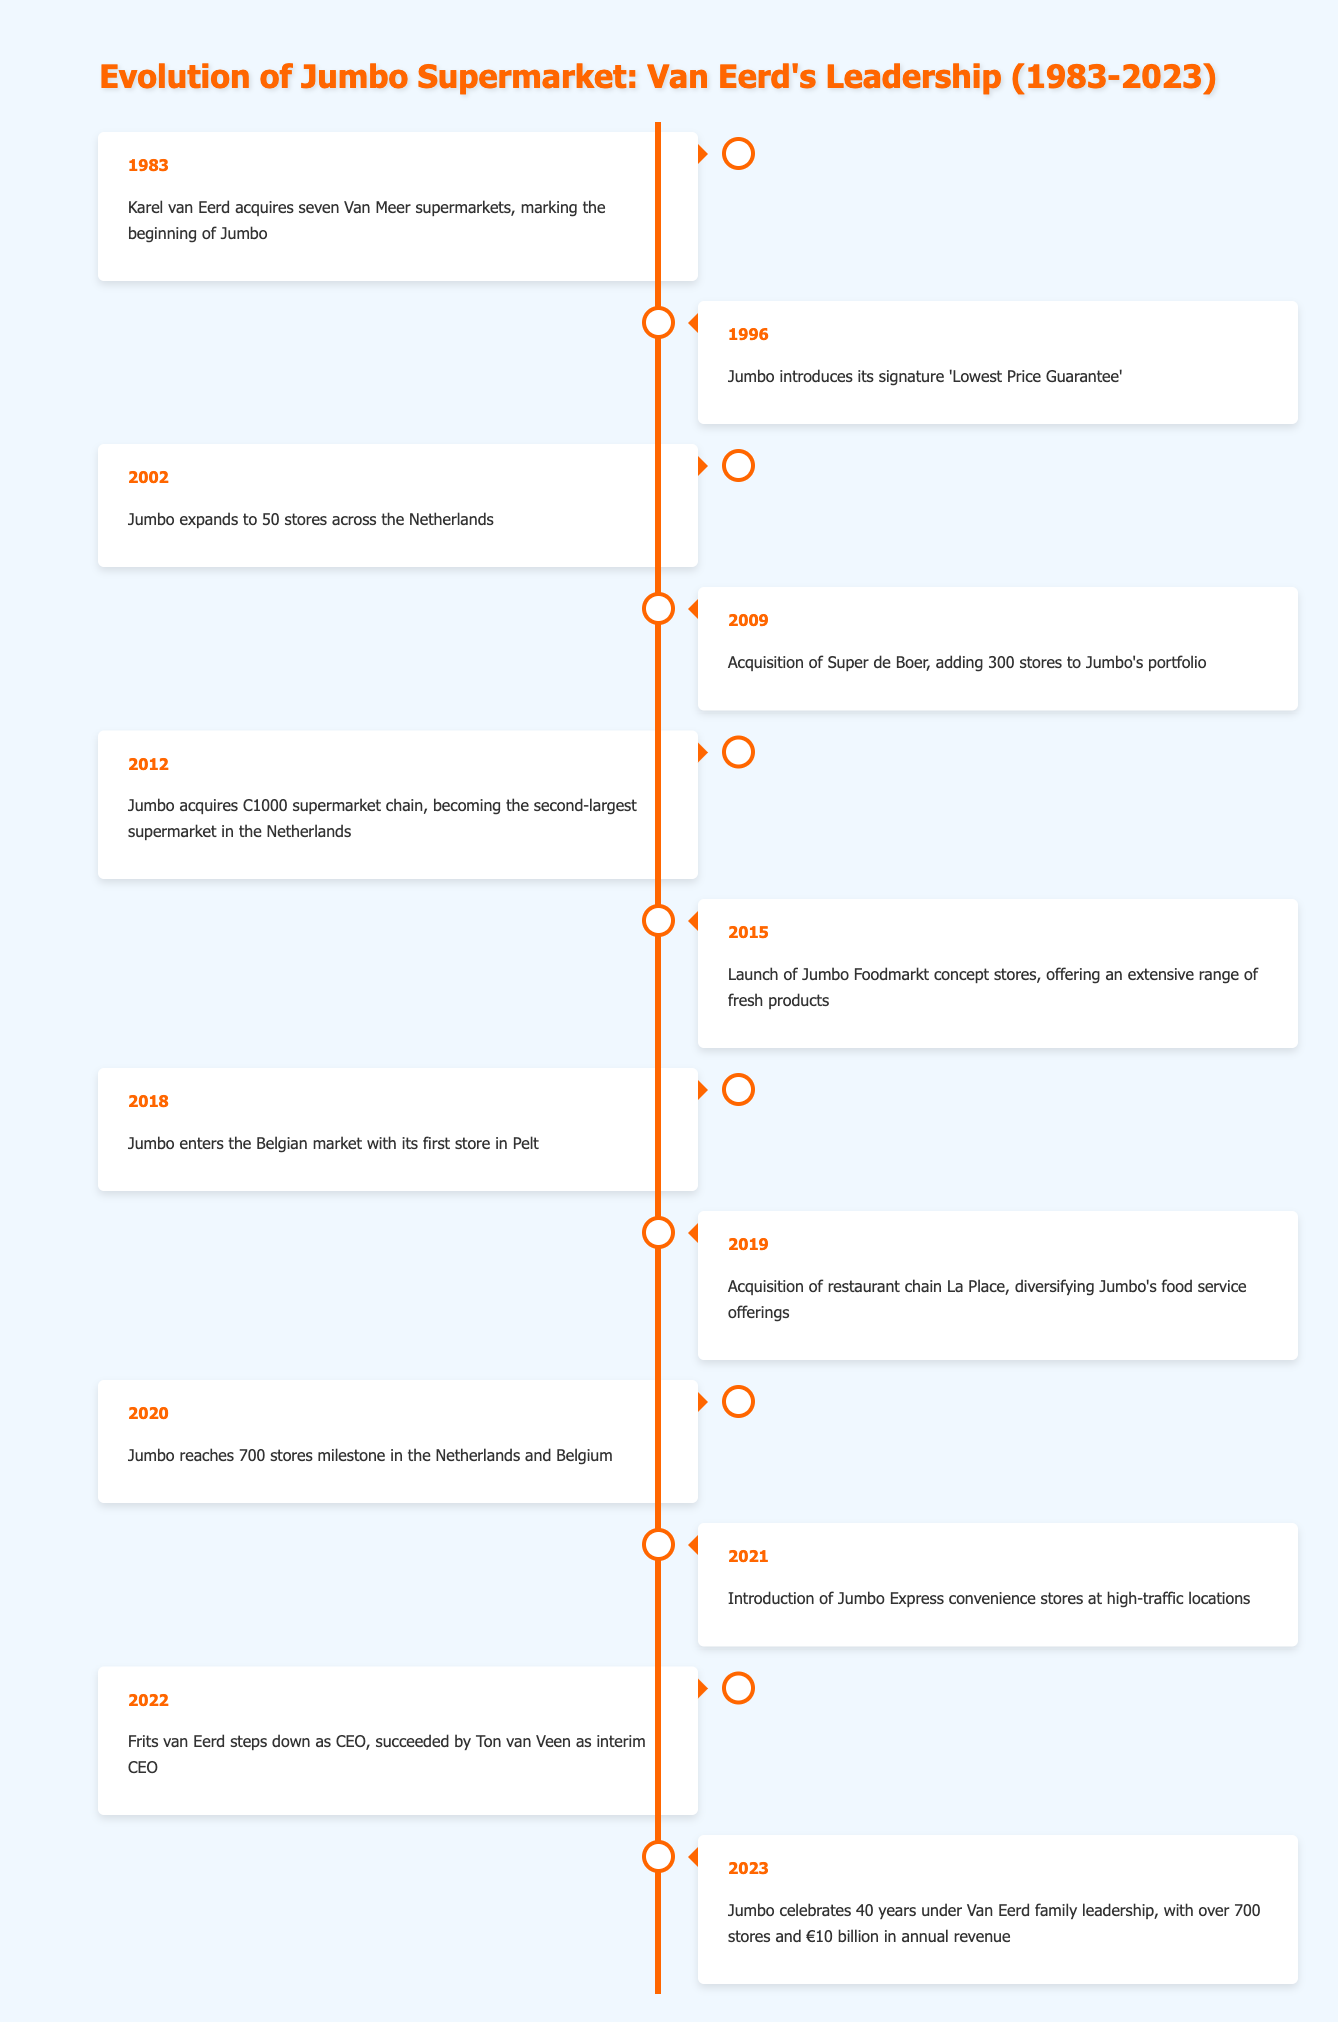What year did Karel van Eerd acquire the first supermarkets? According to the table, Karel van Eerd acquired seven Van Meer supermarkets in 1983, which marks the beginning of the Jumbo supermarket chain.
Answer: 1983 What event marked Jumbo becoming the second-largest supermarket in the Netherlands? The table indicates that in 2012, Jumbo acquires the C1000 supermarket chain, which led to its position as the second-largest supermarket in the Netherlands.
Answer: Acquisition of C1000 in 2012 How many stores did Jumbo have after acquiring Super de Boer in 2009? The acquisition of Super de Boer in 2009 added 300 stores to Jumbo's portfolio. However, to find the total, we need to consider their previous store count, which was not stated in the table. Therefore, we can't determine the total number of stores post-acquisition without additional information.
Answer: Cannot be determined Did Jumbo enter the Belgian market before or after reaching 700 stores? The table shows that Jumbo entered the Belgian market in 2018 and reached 700 stores in 2020, indicating that Belgium was entered before reaching that store milestone.
Answer: Before What is the difference in years between the introduction of Jumbo's 'Lowest Price Guarantee' and the acquisition of C1000? The 'Lowest Price Guarantee' was introduced in 1996, and the acquisition of C1000 occurred in 2012. Therefore, the difference is 2012 - 1996 = 16 years.
Answer: 16 years What year did Jumbo celebrate 40 years under Van Eerd family leadership? According to the table, Jumbo celebrated 40 years of Van Eerd family leadership in 2023.
Answer: 2023 How many major acquisitions did Jumbo make between 2009 and 2019? The table lists two major acquisitions: Super de Boer in 2009 and La Place in 2019. Therefore, there are two major acquisitions made by Jumbo during that period.
Answer: 2 Was the introduction of Jumbo Express convenience stores in 2021 a diversification of offerings? Introducing Jumbo Express convenience stores allowed for expanding the range of locations and services offered by Jumbo, which aligns with diversification. Thus, the answer is yes.
Answer: Yes What is the total number of years from the founding of Jumbo to the step down of Frits van Eerd as CEO? Jumbo was founded in 1983 and Frits van Eerd stepped down as CEO in 2022, so the total number of years is 2022 - 1983 = 39 years.
Answer: 39 years 